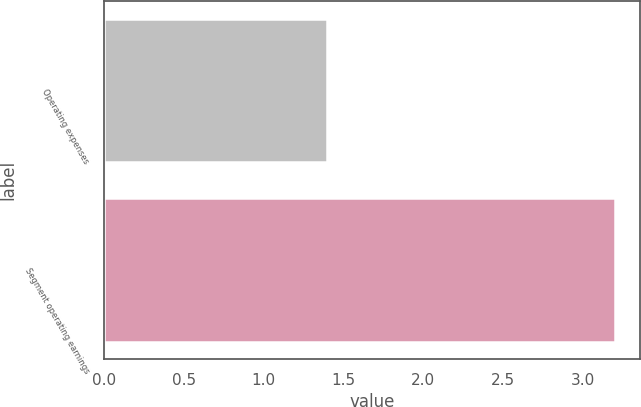<chart> <loc_0><loc_0><loc_500><loc_500><bar_chart><fcel>Operating expenses<fcel>Segment operating earnings<nl><fcel>1.4<fcel>3.2<nl></chart> 